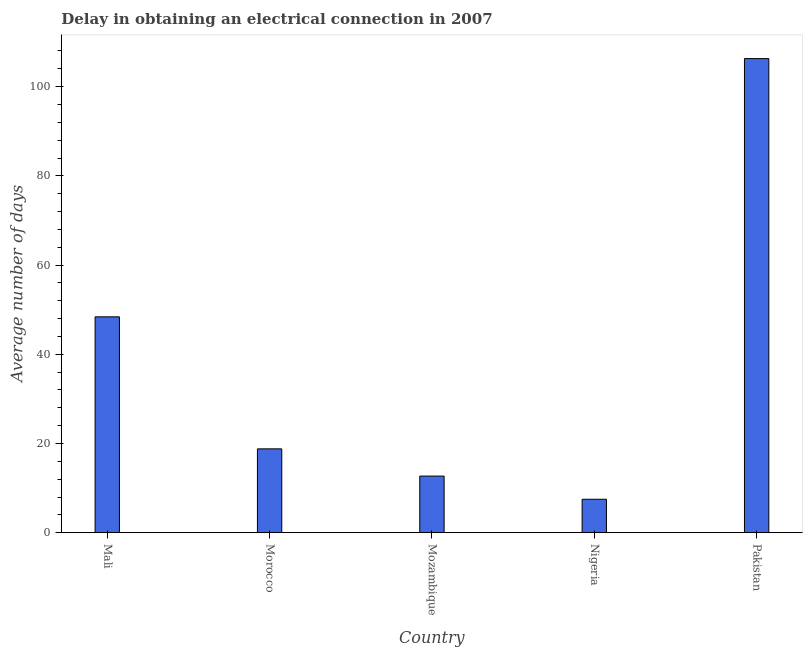Does the graph contain any zero values?
Provide a succinct answer. No. What is the title of the graph?
Give a very brief answer. Delay in obtaining an electrical connection in 2007. What is the label or title of the X-axis?
Your response must be concise. Country. What is the label or title of the Y-axis?
Your answer should be compact. Average number of days. What is the dalay in electrical connection in Pakistan?
Provide a succinct answer. 106.3. Across all countries, what is the maximum dalay in electrical connection?
Your answer should be very brief. 106.3. Across all countries, what is the minimum dalay in electrical connection?
Offer a terse response. 7.5. In which country was the dalay in electrical connection maximum?
Give a very brief answer. Pakistan. In which country was the dalay in electrical connection minimum?
Provide a short and direct response. Nigeria. What is the sum of the dalay in electrical connection?
Your response must be concise. 193.7. What is the difference between the dalay in electrical connection in Mali and Mozambique?
Offer a terse response. 35.7. What is the average dalay in electrical connection per country?
Your response must be concise. 38.74. In how many countries, is the dalay in electrical connection greater than 44 days?
Provide a short and direct response. 2. What is the ratio of the dalay in electrical connection in Morocco to that in Mozambique?
Offer a terse response. 1.48. Is the dalay in electrical connection in Mozambique less than that in Nigeria?
Make the answer very short. No. What is the difference between the highest and the second highest dalay in electrical connection?
Ensure brevity in your answer.  57.9. What is the difference between the highest and the lowest dalay in electrical connection?
Provide a succinct answer. 98.8. How many countries are there in the graph?
Keep it short and to the point. 5. Are the values on the major ticks of Y-axis written in scientific E-notation?
Make the answer very short. No. What is the Average number of days of Mali?
Ensure brevity in your answer.  48.4. What is the Average number of days of Morocco?
Offer a terse response. 18.8. What is the Average number of days in Pakistan?
Provide a succinct answer. 106.3. What is the difference between the Average number of days in Mali and Morocco?
Your answer should be compact. 29.6. What is the difference between the Average number of days in Mali and Mozambique?
Give a very brief answer. 35.7. What is the difference between the Average number of days in Mali and Nigeria?
Offer a terse response. 40.9. What is the difference between the Average number of days in Mali and Pakistan?
Your response must be concise. -57.9. What is the difference between the Average number of days in Morocco and Mozambique?
Your answer should be very brief. 6.1. What is the difference between the Average number of days in Morocco and Pakistan?
Make the answer very short. -87.5. What is the difference between the Average number of days in Mozambique and Pakistan?
Your answer should be compact. -93.6. What is the difference between the Average number of days in Nigeria and Pakistan?
Give a very brief answer. -98.8. What is the ratio of the Average number of days in Mali to that in Morocco?
Provide a succinct answer. 2.57. What is the ratio of the Average number of days in Mali to that in Mozambique?
Offer a very short reply. 3.81. What is the ratio of the Average number of days in Mali to that in Nigeria?
Provide a short and direct response. 6.45. What is the ratio of the Average number of days in Mali to that in Pakistan?
Your answer should be very brief. 0.46. What is the ratio of the Average number of days in Morocco to that in Mozambique?
Provide a succinct answer. 1.48. What is the ratio of the Average number of days in Morocco to that in Nigeria?
Offer a very short reply. 2.51. What is the ratio of the Average number of days in Morocco to that in Pakistan?
Your response must be concise. 0.18. What is the ratio of the Average number of days in Mozambique to that in Nigeria?
Provide a short and direct response. 1.69. What is the ratio of the Average number of days in Mozambique to that in Pakistan?
Provide a short and direct response. 0.12. What is the ratio of the Average number of days in Nigeria to that in Pakistan?
Provide a short and direct response. 0.07. 